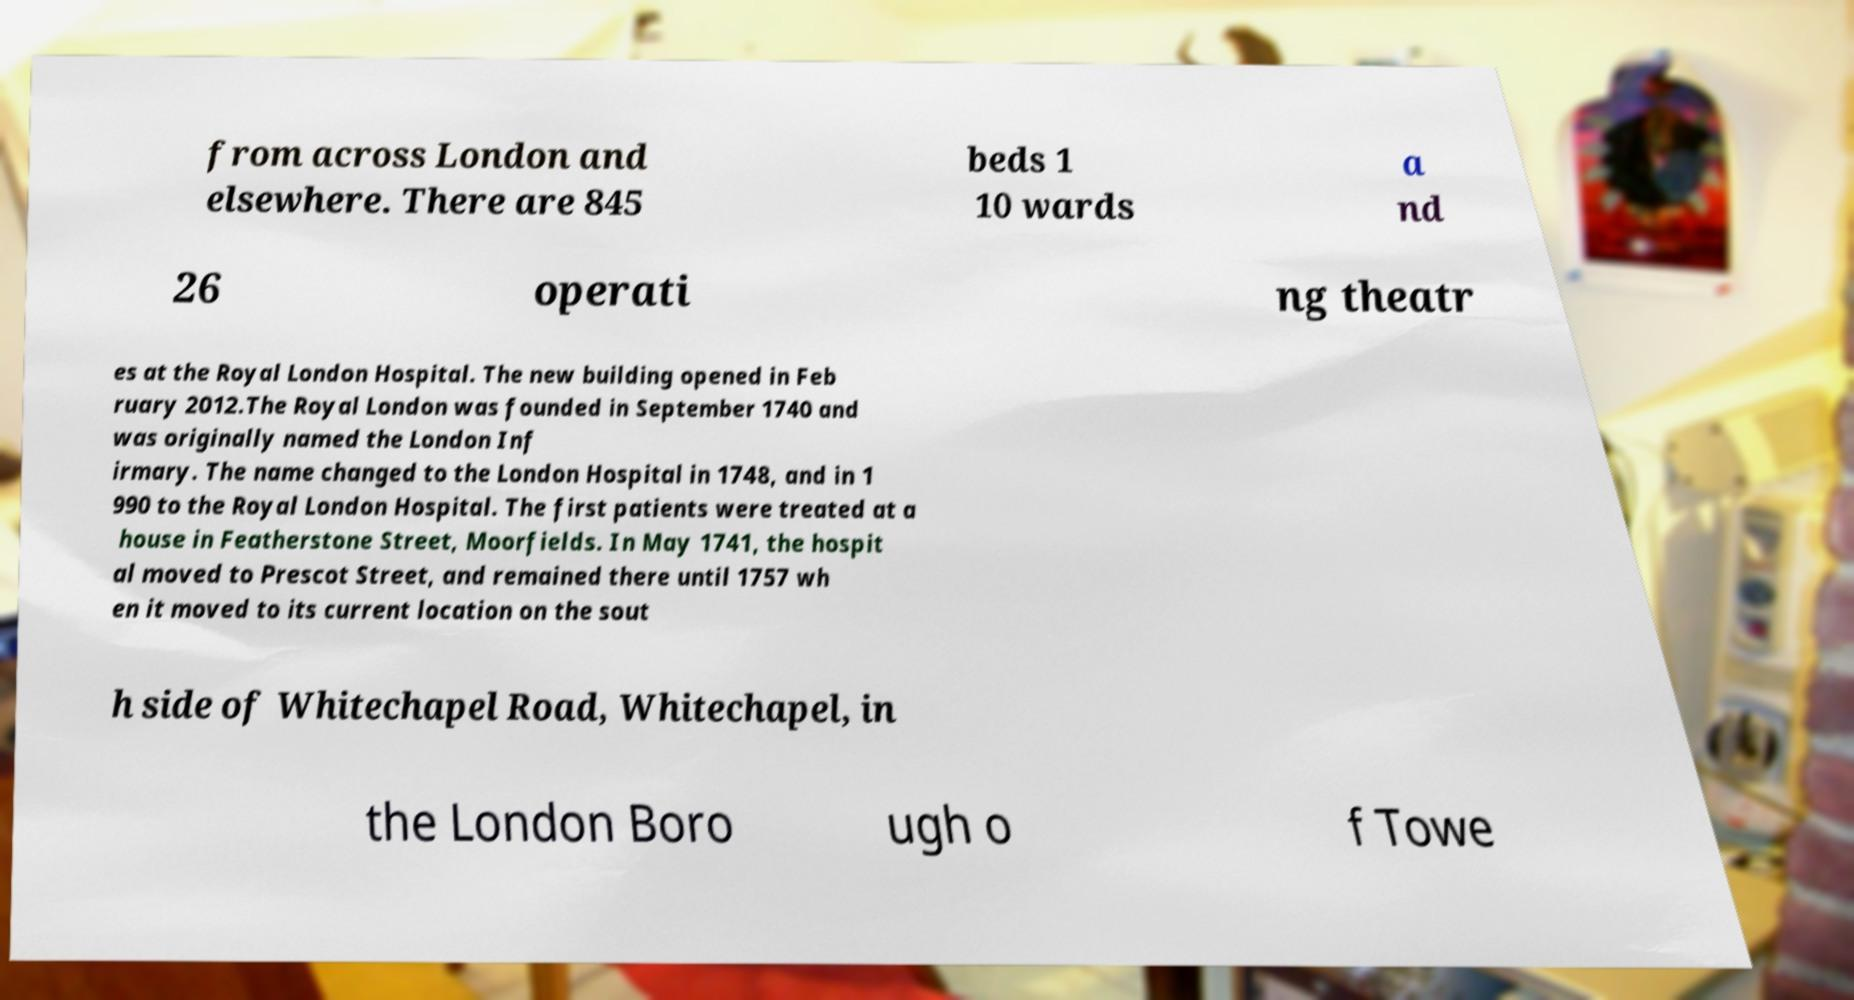Could you extract and type out the text from this image? from across London and elsewhere. There are 845 beds 1 10 wards a nd 26 operati ng theatr es at the Royal London Hospital. The new building opened in Feb ruary 2012.The Royal London was founded in September 1740 and was originally named the London Inf irmary. The name changed to the London Hospital in 1748, and in 1 990 to the Royal London Hospital. The first patients were treated at a house in Featherstone Street, Moorfields. In May 1741, the hospit al moved to Prescot Street, and remained there until 1757 wh en it moved to its current location on the sout h side of Whitechapel Road, Whitechapel, in the London Boro ugh o f Towe 